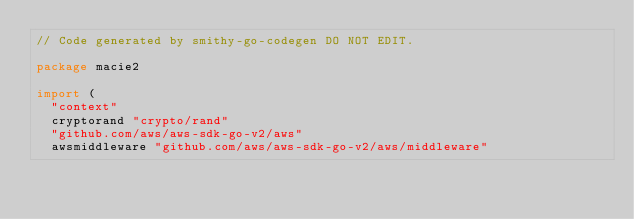<code> <loc_0><loc_0><loc_500><loc_500><_Go_>// Code generated by smithy-go-codegen DO NOT EDIT.

package macie2

import (
	"context"
	cryptorand "crypto/rand"
	"github.com/aws/aws-sdk-go-v2/aws"
	awsmiddleware "github.com/aws/aws-sdk-go-v2/aws/middleware"</code> 